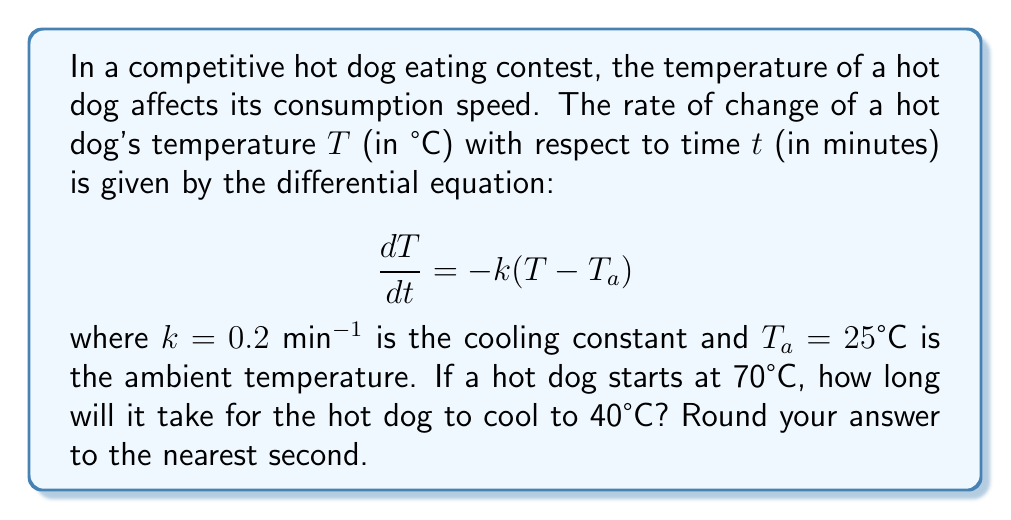Provide a solution to this math problem. Let's solve this problem step by step:

1) The given differential equation is a first-order linear differential equation:

   $$\frac{dT}{dt} = -k(T - T_a)$$

2) This equation can be solved by separation of variables. First, rearrange the equation:

   $$\frac{dT}{T - T_a} = -k dt$$

3) Integrate both sides:

   $$\int \frac{dT}{T - T_a} = -k \int dt$$

4) This gives us:

   $$\ln|T - T_a| = -kt + C$$

5) Solve for T:

   $$T - T_a = Ce^{-kt}$$
   $$T = T_a + Ce^{-kt}$$

6) Use the initial condition to find C. At t = 0, T = 70°C:

   $$70 = 25 + C$$
   $$C = 45$$

7) So our solution is:

   $$T = 25 + 45e^{-0.2t}$$

8) Now, we want to find t when T = 40°C:

   $$40 = 25 + 45e^{-0.2t}$$

9) Solve for t:

   $$15 = 45e^{-0.2t}$$
   $$\frac{1}{3} = e^{-0.2t}$$
   $$\ln(\frac{1}{3}) = -0.2t$$
   $$t = -\frac{\ln(\frac{1}{3})}{0.2} = \frac{\ln(3)}{0.2} \approx 5.4931 \text{ minutes}$$

10) Converting to seconds and rounding:

    $$5.4931 \times 60 \approx 329.59 \text{ seconds}$$

    Rounded to the nearest second, this is 330 seconds.
Answer: 330 seconds 